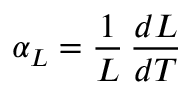Convert formula to latex. <formula><loc_0><loc_0><loc_500><loc_500>\alpha _ { L } = { \frac { 1 } { L } } \, { \frac { d L } { d T } }</formula> 